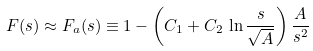Convert formula to latex. <formula><loc_0><loc_0><loc_500><loc_500>\, F ( s ) \approx F _ { a } ( s ) \equiv 1 - \left ( C _ { 1 } + C _ { 2 } \, \ln \frac { s } { \sqrt { A } } \right ) \frac { A } { s ^ { 2 } }</formula> 